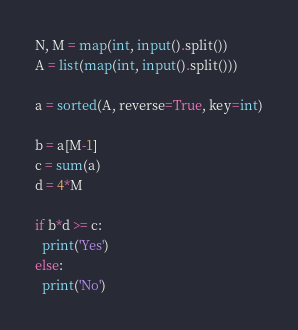Convert code to text. <code><loc_0><loc_0><loc_500><loc_500><_Python_>N, M = map(int, input().split())
A = list(map(int, input().split()))

a = sorted(A, reverse=True, key=int)

b = a[M-1]
c = sum(a)
d = 4*M

if b*d >= c:
  print('Yes')
else:
  print('No')
</code> 